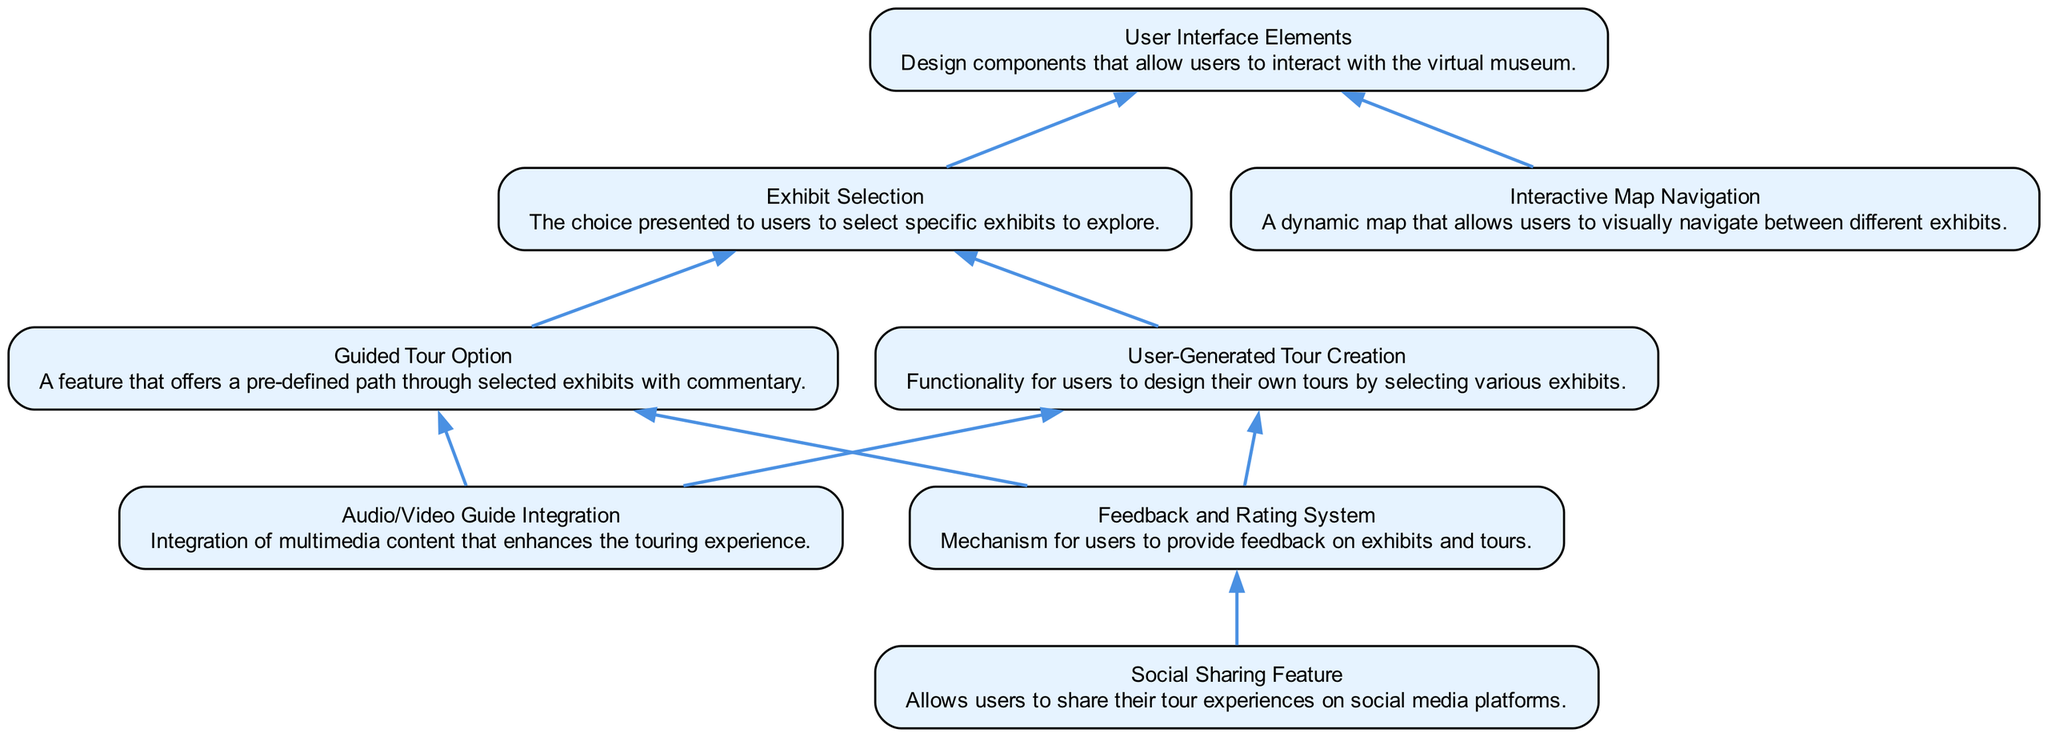What is the total number of nodes in the diagram? The diagram contains eight distinct elements represented as nodes. Each element, such as 'User Interface Elements' and 'Exhibit Selection', is a separate node contributing to the total count.
Answer: eight Which element is connected directly to the 'Exhibit Selection' node? The 'Exhibit Selection' node has two direct connections: one going to the 'Guided Tour Option' and another going to the 'User-Generated Tour Creation'. Each connection indicates a direct relationship from 'Exhibit Selection' to these nodes.
Answer: Guided Tour Option, User-Generated Tour Creation What functionality does 'Interactive Map Navigation' enable? The 'Interactive Map Navigation' node is linked to the 'User Interface Elements', indicating that it allows users to navigate between different exhibits visually, enhancing the exploration experience.
Answer: Navigation between exhibits visually How many edges connect to the 'Guided Tour Option'? The 'Guided Tour Option' has three direct connections represented as edges: one to 'Exhibit Selection', one to 'Audio/Video Guide Integration', and another to 'Feedback and Rating System'. Each edge signifies a relationship that the 'Guided Tour Option' has with other elements.
Answer: three What element provides users the ability to share their experiences? The 'Social Sharing Feature' element explicitly states its role in enabling users to share their tour experiences on social media platforms, indicating that it focuses on promoting interaction outside the virtual museum.
Answer: Social Sharing Feature Which element requires user input for its function? The 'User-Generated Tour Creation' element revolves around user interaction, as it allows users to design their own tours by selecting from various exhibits, making it dependent on user input.
Answer: User-Generated Tour Creation What type of input does the 'Feedback and Rating System' accept? This system is designed to gather user inputs in the form of feedback and ratings on exhibits and tours, thus it actively seeks user contributions regarding their experiences.
Answer: User feedback and ratings How many nodes have a direct connection to the 'Feedback and Rating System'? There are two nodes connected directly to the 'Feedback and Rating System': 'Guided Tour Option' and 'User-Generated Tour Creation'. Each connection shows how feedback can be associated with these elements.
Answer: two 